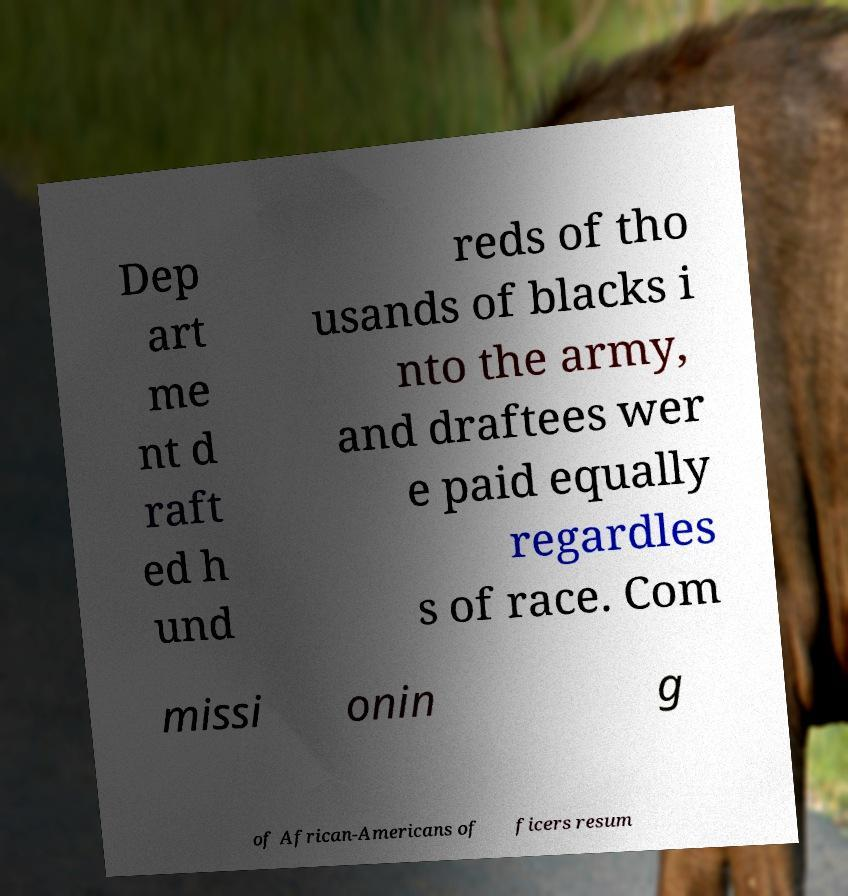Can you read and provide the text displayed in the image?This photo seems to have some interesting text. Can you extract and type it out for me? Dep art me nt d raft ed h und reds of tho usands of blacks i nto the army, and draftees wer e paid equally regardles s of race. Com missi onin g of African-Americans of ficers resum 